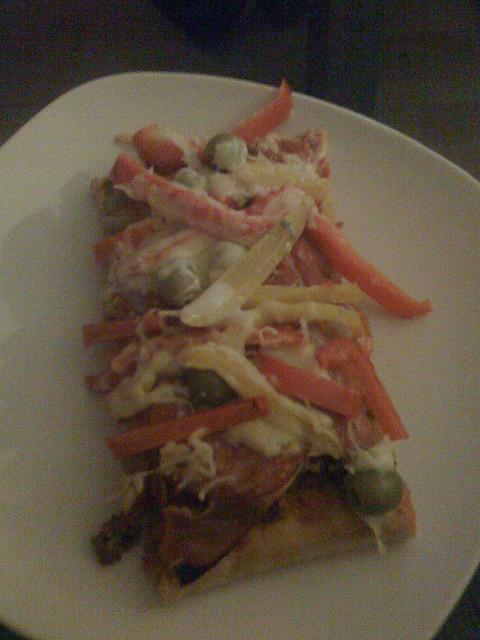What pork product can you identify?
Keep it brief. Bacon. What are the round green things?
Concise answer only. Olives. What are the orange stick things?
Short answer required. Carrots. 